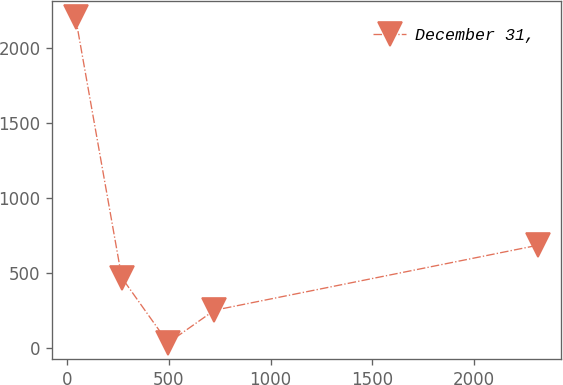Convert chart. <chart><loc_0><loc_0><loc_500><loc_500><line_chart><ecel><fcel>December 31,<nl><fcel>41.2<fcel>2202.5<nl><fcel>268.59<fcel>469.27<nl><fcel>495.98<fcel>35.95<nl><fcel>723.37<fcel>252.61<nl><fcel>2315.1<fcel>685.92<nl></chart> 